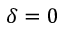Convert formula to latex. <formula><loc_0><loc_0><loc_500><loc_500>\delta = 0</formula> 